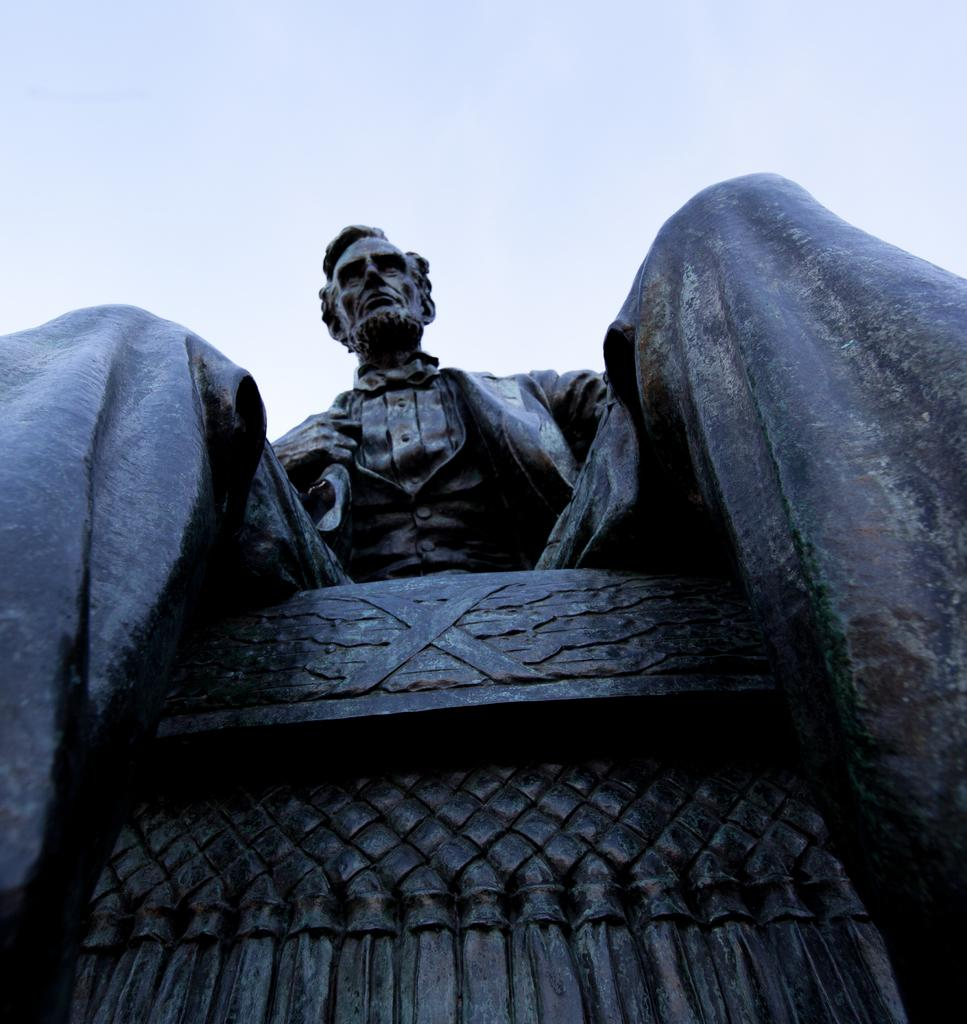What is the main subject of the image? There is a statue of a man in the image. How is the statue positioned in the image? The statue is sitting on a platform. What can be seen in the background of the image? The sky is visible in the background of the image. What type of eggnog is being served at the statue's feet in the image? There is no eggnog present in the image; it features a statue of a man sitting on a platform with the sky visible in the background. 